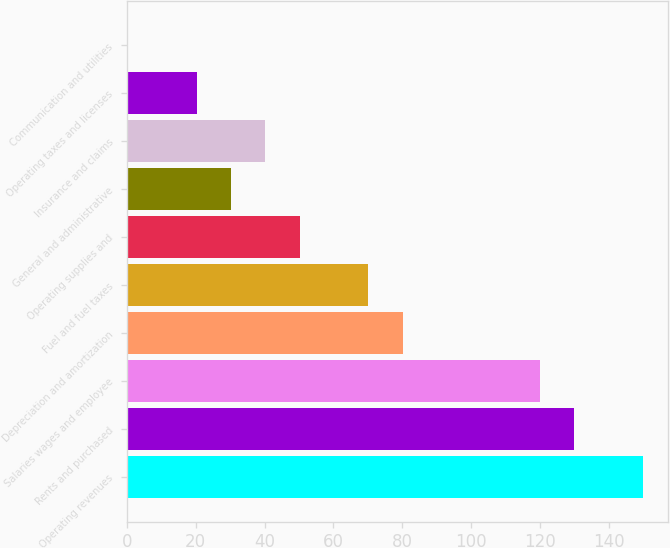Convert chart. <chart><loc_0><loc_0><loc_500><loc_500><bar_chart><fcel>Operating revenues<fcel>Rents and purchased<fcel>Salaries wages and employee<fcel>Depreciation and amortization<fcel>Fuel and fuel taxes<fcel>Operating supplies and<fcel>General and administrative<fcel>Insurance and claims<fcel>Operating taxes and licenses<fcel>Communication and utilities<nl><fcel>149.85<fcel>129.91<fcel>119.94<fcel>80.06<fcel>70.09<fcel>50.15<fcel>30.21<fcel>40.18<fcel>20.24<fcel>0.3<nl></chart> 